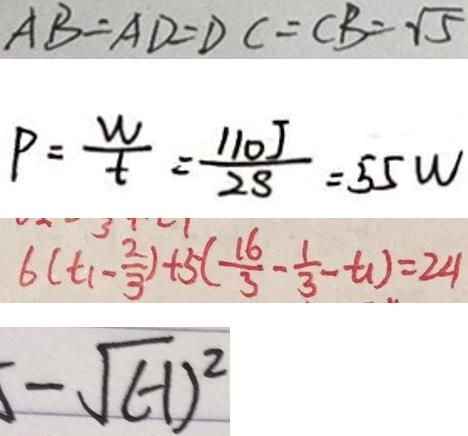Convert formula to latex. <formula><loc_0><loc_0><loc_500><loc_500>A B = A D = D C = C B = \sqrt { 5 } 
 P = \frac { w } { t } = \frac { 1 1 0 J } { 2 8 } = 5 5 w 
 6 ( t _ { 1 } - \frac { 2 } { 3 } ) + 5 ( \frac { 1 6 } { 3 } - \frac { 1 } { 3 } - t _ { 1 } ) = 2 4 
 - \sqrt { ( - 1 ) ^ { 2 } }</formula> 